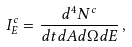Convert formula to latex. <formula><loc_0><loc_0><loc_500><loc_500>I ^ { c } _ { E } = \frac { d ^ { 4 } N ^ { c } } { d t d A d \Omega d E } \, ,</formula> 